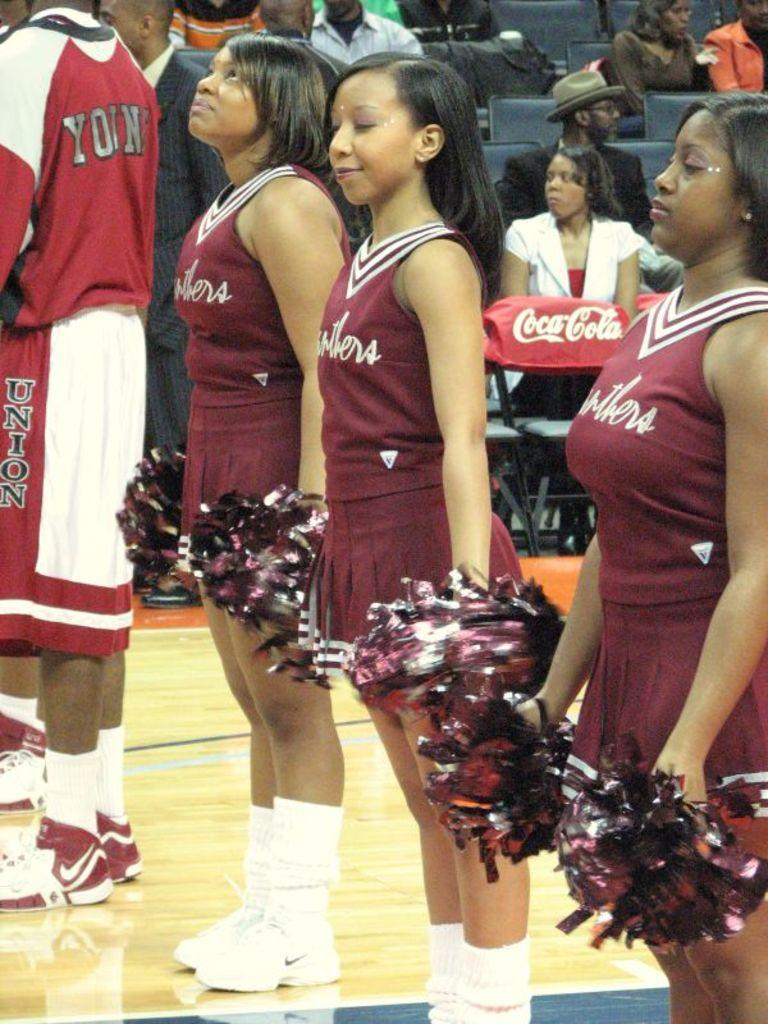<image>
Create a compact narrative representing the image presented. A basketball player with Union on his shorts stands next to three cheerleaders. 